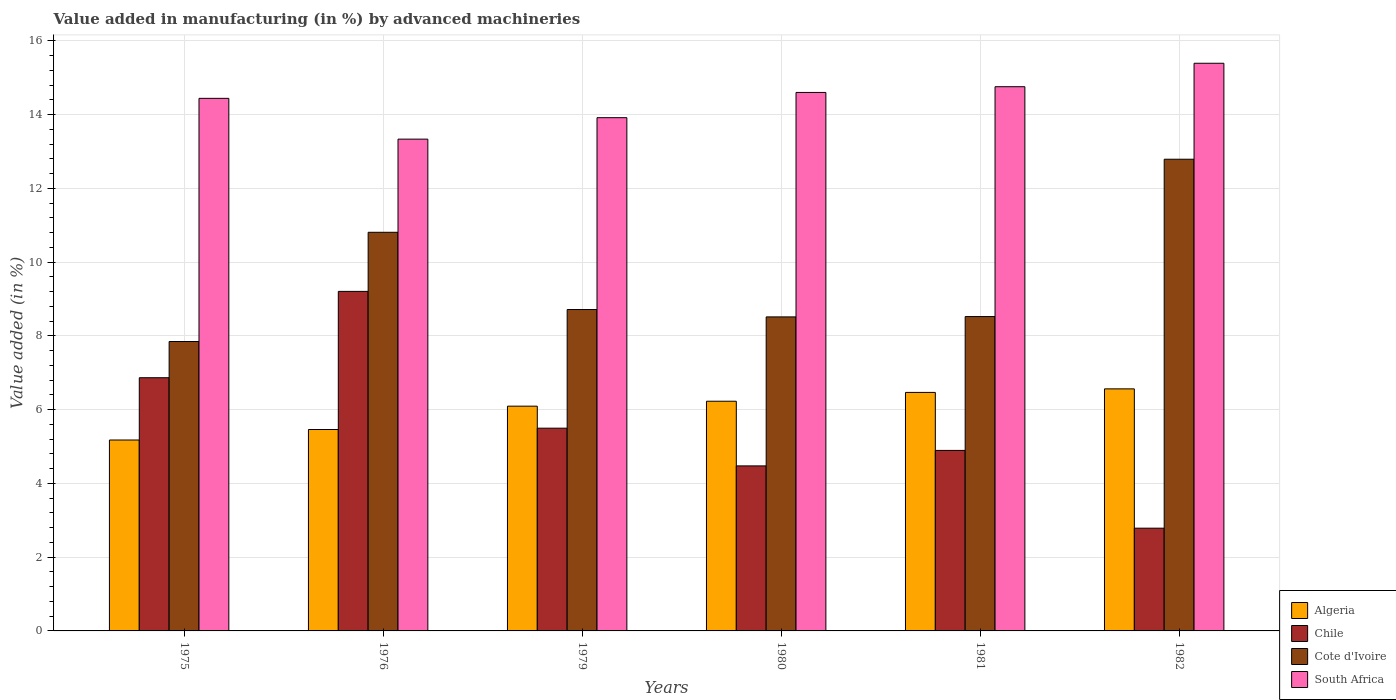How many groups of bars are there?
Make the answer very short. 6. Are the number of bars on each tick of the X-axis equal?
Offer a very short reply. Yes. How many bars are there on the 1st tick from the left?
Offer a terse response. 4. In how many cases, is the number of bars for a given year not equal to the number of legend labels?
Your answer should be compact. 0. What is the percentage of value added in manufacturing by advanced machineries in Chile in 1982?
Provide a short and direct response. 2.79. Across all years, what is the maximum percentage of value added in manufacturing by advanced machineries in Chile?
Your answer should be compact. 9.21. Across all years, what is the minimum percentage of value added in manufacturing by advanced machineries in Algeria?
Offer a terse response. 5.18. In which year was the percentage of value added in manufacturing by advanced machineries in Chile maximum?
Offer a terse response. 1976. In which year was the percentage of value added in manufacturing by advanced machineries in South Africa minimum?
Your response must be concise. 1976. What is the total percentage of value added in manufacturing by advanced machineries in Chile in the graph?
Provide a short and direct response. 33.73. What is the difference between the percentage of value added in manufacturing by advanced machineries in Cote d'Ivoire in 1981 and that in 1982?
Your answer should be very brief. -4.27. What is the difference between the percentage of value added in manufacturing by advanced machineries in Cote d'Ivoire in 1981 and the percentage of value added in manufacturing by advanced machineries in Chile in 1976?
Give a very brief answer. -0.68. What is the average percentage of value added in manufacturing by advanced machineries in Cote d'Ivoire per year?
Ensure brevity in your answer.  9.54. In the year 1981, what is the difference between the percentage of value added in manufacturing by advanced machineries in Algeria and percentage of value added in manufacturing by advanced machineries in Chile?
Offer a very short reply. 1.57. What is the ratio of the percentage of value added in manufacturing by advanced machineries in Cote d'Ivoire in 1975 to that in 1982?
Offer a terse response. 0.61. Is the percentage of value added in manufacturing by advanced machineries in South Africa in 1975 less than that in 1979?
Keep it short and to the point. No. Is the difference between the percentage of value added in manufacturing by advanced machineries in Algeria in 1975 and 1982 greater than the difference between the percentage of value added in manufacturing by advanced machineries in Chile in 1975 and 1982?
Offer a very short reply. No. What is the difference between the highest and the second highest percentage of value added in manufacturing by advanced machineries in Algeria?
Offer a terse response. 0.1. What is the difference between the highest and the lowest percentage of value added in manufacturing by advanced machineries in Chile?
Ensure brevity in your answer.  6.42. In how many years, is the percentage of value added in manufacturing by advanced machineries in Chile greater than the average percentage of value added in manufacturing by advanced machineries in Chile taken over all years?
Your answer should be very brief. 2. Is the sum of the percentage of value added in manufacturing by advanced machineries in South Africa in 1976 and 1981 greater than the maximum percentage of value added in manufacturing by advanced machineries in Cote d'Ivoire across all years?
Make the answer very short. Yes. Is it the case that in every year, the sum of the percentage of value added in manufacturing by advanced machineries in Algeria and percentage of value added in manufacturing by advanced machineries in South Africa is greater than the sum of percentage of value added in manufacturing by advanced machineries in Chile and percentage of value added in manufacturing by advanced machineries in Cote d'Ivoire?
Provide a succinct answer. Yes. What does the 1st bar from the left in 1980 represents?
Provide a succinct answer. Algeria. How many bars are there?
Offer a terse response. 24. Are all the bars in the graph horizontal?
Offer a very short reply. No. What is the difference between two consecutive major ticks on the Y-axis?
Offer a terse response. 2. Does the graph contain any zero values?
Provide a succinct answer. No. Where does the legend appear in the graph?
Give a very brief answer. Bottom right. What is the title of the graph?
Ensure brevity in your answer.  Value added in manufacturing (in %) by advanced machineries. What is the label or title of the X-axis?
Your response must be concise. Years. What is the label or title of the Y-axis?
Ensure brevity in your answer.  Value added (in %). What is the Value added (in %) in Algeria in 1975?
Keep it short and to the point. 5.18. What is the Value added (in %) of Chile in 1975?
Ensure brevity in your answer.  6.87. What is the Value added (in %) of Cote d'Ivoire in 1975?
Make the answer very short. 7.85. What is the Value added (in %) of South Africa in 1975?
Offer a very short reply. 14.44. What is the Value added (in %) of Algeria in 1976?
Offer a very short reply. 5.46. What is the Value added (in %) in Chile in 1976?
Your answer should be compact. 9.21. What is the Value added (in %) of Cote d'Ivoire in 1976?
Give a very brief answer. 10.81. What is the Value added (in %) in South Africa in 1976?
Ensure brevity in your answer.  13.34. What is the Value added (in %) of Algeria in 1979?
Your answer should be very brief. 6.1. What is the Value added (in %) in Chile in 1979?
Ensure brevity in your answer.  5.5. What is the Value added (in %) of Cote d'Ivoire in 1979?
Offer a very short reply. 8.72. What is the Value added (in %) in South Africa in 1979?
Give a very brief answer. 13.92. What is the Value added (in %) of Algeria in 1980?
Your answer should be compact. 6.23. What is the Value added (in %) in Chile in 1980?
Make the answer very short. 4.48. What is the Value added (in %) in Cote d'Ivoire in 1980?
Provide a succinct answer. 8.52. What is the Value added (in %) of South Africa in 1980?
Offer a very short reply. 14.6. What is the Value added (in %) in Algeria in 1981?
Keep it short and to the point. 6.47. What is the Value added (in %) of Chile in 1981?
Give a very brief answer. 4.9. What is the Value added (in %) of Cote d'Ivoire in 1981?
Your answer should be compact. 8.53. What is the Value added (in %) of South Africa in 1981?
Your answer should be very brief. 14.76. What is the Value added (in %) in Algeria in 1982?
Your answer should be very brief. 6.56. What is the Value added (in %) of Chile in 1982?
Give a very brief answer. 2.79. What is the Value added (in %) of Cote d'Ivoire in 1982?
Your answer should be very brief. 12.79. What is the Value added (in %) in South Africa in 1982?
Offer a terse response. 15.4. Across all years, what is the maximum Value added (in %) of Algeria?
Keep it short and to the point. 6.56. Across all years, what is the maximum Value added (in %) of Chile?
Make the answer very short. 9.21. Across all years, what is the maximum Value added (in %) in Cote d'Ivoire?
Provide a succinct answer. 12.79. Across all years, what is the maximum Value added (in %) in South Africa?
Your answer should be very brief. 15.4. Across all years, what is the minimum Value added (in %) in Algeria?
Make the answer very short. 5.18. Across all years, what is the minimum Value added (in %) in Chile?
Your answer should be very brief. 2.79. Across all years, what is the minimum Value added (in %) in Cote d'Ivoire?
Your response must be concise. 7.85. Across all years, what is the minimum Value added (in %) of South Africa?
Make the answer very short. 13.34. What is the total Value added (in %) in Algeria in the graph?
Provide a short and direct response. 36. What is the total Value added (in %) of Chile in the graph?
Give a very brief answer. 33.73. What is the total Value added (in %) of Cote d'Ivoire in the graph?
Ensure brevity in your answer.  57.21. What is the total Value added (in %) in South Africa in the graph?
Your response must be concise. 86.46. What is the difference between the Value added (in %) in Algeria in 1975 and that in 1976?
Your answer should be very brief. -0.28. What is the difference between the Value added (in %) in Chile in 1975 and that in 1976?
Offer a terse response. -2.34. What is the difference between the Value added (in %) of Cote d'Ivoire in 1975 and that in 1976?
Your answer should be compact. -2.96. What is the difference between the Value added (in %) of South Africa in 1975 and that in 1976?
Your answer should be very brief. 1.11. What is the difference between the Value added (in %) of Algeria in 1975 and that in 1979?
Your answer should be compact. -0.92. What is the difference between the Value added (in %) of Chile in 1975 and that in 1979?
Provide a short and direct response. 1.37. What is the difference between the Value added (in %) of Cote d'Ivoire in 1975 and that in 1979?
Provide a short and direct response. -0.87. What is the difference between the Value added (in %) of South Africa in 1975 and that in 1979?
Ensure brevity in your answer.  0.52. What is the difference between the Value added (in %) of Algeria in 1975 and that in 1980?
Your answer should be very brief. -1.05. What is the difference between the Value added (in %) in Chile in 1975 and that in 1980?
Give a very brief answer. 2.39. What is the difference between the Value added (in %) in Cote d'Ivoire in 1975 and that in 1980?
Your answer should be compact. -0.67. What is the difference between the Value added (in %) in South Africa in 1975 and that in 1980?
Give a very brief answer. -0.16. What is the difference between the Value added (in %) in Algeria in 1975 and that in 1981?
Provide a succinct answer. -1.29. What is the difference between the Value added (in %) in Chile in 1975 and that in 1981?
Your response must be concise. 1.97. What is the difference between the Value added (in %) of Cote d'Ivoire in 1975 and that in 1981?
Offer a very short reply. -0.68. What is the difference between the Value added (in %) of South Africa in 1975 and that in 1981?
Ensure brevity in your answer.  -0.32. What is the difference between the Value added (in %) of Algeria in 1975 and that in 1982?
Your answer should be very brief. -1.39. What is the difference between the Value added (in %) in Chile in 1975 and that in 1982?
Provide a succinct answer. 4.08. What is the difference between the Value added (in %) in Cote d'Ivoire in 1975 and that in 1982?
Provide a short and direct response. -4.94. What is the difference between the Value added (in %) in South Africa in 1975 and that in 1982?
Your answer should be compact. -0.95. What is the difference between the Value added (in %) of Algeria in 1976 and that in 1979?
Provide a short and direct response. -0.63. What is the difference between the Value added (in %) in Chile in 1976 and that in 1979?
Provide a short and direct response. 3.71. What is the difference between the Value added (in %) of Cote d'Ivoire in 1976 and that in 1979?
Provide a short and direct response. 2.09. What is the difference between the Value added (in %) of South Africa in 1976 and that in 1979?
Make the answer very short. -0.58. What is the difference between the Value added (in %) in Algeria in 1976 and that in 1980?
Make the answer very short. -0.77. What is the difference between the Value added (in %) in Chile in 1976 and that in 1980?
Make the answer very short. 4.73. What is the difference between the Value added (in %) of Cote d'Ivoire in 1976 and that in 1980?
Your answer should be very brief. 2.29. What is the difference between the Value added (in %) in South Africa in 1976 and that in 1980?
Ensure brevity in your answer.  -1.27. What is the difference between the Value added (in %) in Algeria in 1976 and that in 1981?
Your answer should be compact. -1.01. What is the difference between the Value added (in %) of Chile in 1976 and that in 1981?
Offer a terse response. 4.31. What is the difference between the Value added (in %) in Cote d'Ivoire in 1976 and that in 1981?
Offer a very short reply. 2.29. What is the difference between the Value added (in %) in South Africa in 1976 and that in 1981?
Provide a short and direct response. -1.42. What is the difference between the Value added (in %) of Algeria in 1976 and that in 1982?
Your response must be concise. -1.1. What is the difference between the Value added (in %) in Chile in 1976 and that in 1982?
Your response must be concise. 6.42. What is the difference between the Value added (in %) of Cote d'Ivoire in 1976 and that in 1982?
Keep it short and to the point. -1.98. What is the difference between the Value added (in %) of South Africa in 1976 and that in 1982?
Provide a short and direct response. -2.06. What is the difference between the Value added (in %) of Algeria in 1979 and that in 1980?
Offer a very short reply. -0.13. What is the difference between the Value added (in %) of Chile in 1979 and that in 1980?
Make the answer very short. 1.02. What is the difference between the Value added (in %) in Cote d'Ivoire in 1979 and that in 1980?
Your response must be concise. 0.2. What is the difference between the Value added (in %) in South Africa in 1979 and that in 1980?
Your answer should be compact. -0.68. What is the difference between the Value added (in %) of Algeria in 1979 and that in 1981?
Offer a terse response. -0.37. What is the difference between the Value added (in %) in Chile in 1979 and that in 1981?
Give a very brief answer. 0.6. What is the difference between the Value added (in %) of Cote d'Ivoire in 1979 and that in 1981?
Provide a succinct answer. 0.19. What is the difference between the Value added (in %) in South Africa in 1979 and that in 1981?
Ensure brevity in your answer.  -0.84. What is the difference between the Value added (in %) in Algeria in 1979 and that in 1982?
Offer a terse response. -0.47. What is the difference between the Value added (in %) of Chile in 1979 and that in 1982?
Keep it short and to the point. 2.71. What is the difference between the Value added (in %) in Cote d'Ivoire in 1979 and that in 1982?
Give a very brief answer. -4.08. What is the difference between the Value added (in %) of South Africa in 1979 and that in 1982?
Make the answer very short. -1.48. What is the difference between the Value added (in %) of Algeria in 1980 and that in 1981?
Give a very brief answer. -0.24. What is the difference between the Value added (in %) in Chile in 1980 and that in 1981?
Your answer should be compact. -0.42. What is the difference between the Value added (in %) of Cote d'Ivoire in 1980 and that in 1981?
Your answer should be very brief. -0.01. What is the difference between the Value added (in %) in South Africa in 1980 and that in 1981?
Provide a succinct answer. -0.16. What is the difference between the Value added (in %) in Algeria in 1980 and that in 1982?
Offer a very short reply. -0.34. What is the difference between the Value added (in %) in Chile in 1980 and that in 1982?
Offer a terse response. 1.69. What is the difference between the Value added (in %) in Cote d'Ivoire in 1980 and that in 1982?
Your response must be concise. -4.28. What is the difference between the Value added (in %) in South Africa in 1980 and that in 1982?
Offer a very short reply. -0.79. What is the difference between the Value added (in %) of Algeria in 1981 and that in 1982?
Make the answer very short. -0.1. What is the difference between the Value added (in %) of Chile in 1981 and that in 1982?
Ensure brevity in your answer.  2.11. What is the difference between the Value added (in %) of Cote d'Ivoire in 1981 and that in 1982?
Make the answer very short. -4.27. What is the difference between the Value added (in %) of South Africa in 1981 and that in 1982?
Give a very brief answer. -0.64. What is the difference between the Value added (in %) of Algeria in 1975 and the Value added (in %) of Chile in 1976?
Give a very brief answer. -4.03. What is the difference between the Value added (in %) of Algeria in 1975 and the Value added (in %) of Cote d'Ivoire in 1976?
Provide a short and direct response. -5.63. What is the difference between the Value added (in %) in Algeria in 1975 and the Value added (in %) in South Africa in 1976?
Keep it short and to the point. -8.16. What is the difference between the Value added (in %) in Chile in 1975 and the Value added (in %) in Cote d'Ivoire in 1976?
Ensure brevity in your answer.  -3.94. What is the difference between the Value added (in %) of Chile in 1975 and the Value added (in %) of South Africa in 1976?
Ensure brevity in your answer.  -6.47. What is the difference between the Value added (in %) in Cote d'Ivoire in 1975 and the Value added (in %) in South Africa in 1976?
Offer a terse response. -5.49. What is the difference between the Value added (in %) of Algeria in 1975 and the Value added (in %) of Chile in 1979?
Give a very brief answer. -0.32. What is the difference between the Value added (in %) of Algeria in 1975 and the Value added (in %) of Cote d'Ivoire in 1979?
Provide a succinct answer. -3.54. What is the difference between the Value added (in %) in Algeria in 1975 and the Value added (in %) in South Africa in 1979?
Offer a very short reply. -8.74. What is the difference between the Value added (in %) in Chile in 1975 and the Value added (in %) in Cote d'Ivoire in 1979?
Provide a short and direct response. -1.85. What is the difference between the Value added (in %) in Chile in 1975 and the Value added (in %) in South Africa in 1979?
Offer a very short reply. -7.05. What is the difference between the Value added (in %) of Cote d'Ivoire in 1975 and the Value added (in %) of South Africa in 1979?
Offer a terse response. -6.07. What is the difference between the Value added (in %) in Algeria in 1975 and the Value added (in %) in Chile in 1980?
Give a very brief answer. 0.7. What is the difference between the Value added (in %) of Algeria in 1975 and the Value added (in %) of Cote d'Ivoire in 1980?
Offer a very short reply. -3.34. What is the difference between the Value added (in %) in Algeria in 1975 and the Value added (in %) in South Africa in 1980?
Ensure brevity in your answer.  -9.43. What is the difference between the Value added (in %) of Chile in 1975 and the Value added (in %) of Cote d'Ivoire in 1980?
Your answer should be very brief. -1.65. What is the difference between the Value added (in %) in Chile in 1975 and the Value added (in %) in South Africa in 1980?
Provide a succinct answer. -7.74. What is the difference between the Value added (in %) in Cote d'Ivoire in 1975 and the Value added (in %) in South Africa in 1980?
Offer a terse response. -6.75. What is the difference between the Value added (in %) in Algeria in 1975 and the Value added (in %) in Chile in 1981?
Offer a terse response. 0.28. What is the difference between the Value added (in %) in Algeria in 1975 and the Value added (in %) in Cote d'Ivoire in 1981?
Your response must be concise. -3.35. What is the difference between the Value added (in %) of Algeria in 1975 and the Value added (in %) of South Africa in 1981?
Your answer should be compact. -9.58. What is the difference between the Value added (in %) of Chile in 1975 and the Value added (in %) of Cote d'Ivoire in 1981?
Make the answer very short. -1.66. What is the difference between the Value added (in %) of Chile in 1975 and the Value added (in %) of South Africa in 1981?
Ensure brevity in your answer.  -7.89. What is the difference between the Value added (in %) of Cote d'Ivoire in 1975 and the Value added (in %) of South Africa in 1981?
Keep it short and to the point. -6.91. What is the difference between the Value added (in %) of Algeria in 1975 and the Value added (in %) of Chile in 1982?
Your response must be concise. 2.39. What is the difference between the Value added (in %) of Algeria in 1975 and the Value added (in %) of Cote d'Ivoire in 1982?
Your response must be concise. -7.62. What is the difference between the Value added (in %) in Algeria in 1975 and the Value added (in %) in South Africa in 1982?
Make the answer very short. -10.22. What is the difference between the Value added (in %) in Chile in 1975 and the Value added (in %) in Cote d'Ivoire in 1982?
Your response must be concise. -5.93. What is the difference between the Value added (in %) in Chile in 1975 and the Value added (in %) in South Africa in 1982?
Offer a terse response. -8.53. What is the difference between the Value added (in %) of Cote d'Ivoire in 1975 and the Value added (in %) of South Africa in 1982?
Your response must be concise. -7.55. What is the difference between the Value added (in %) of Algeria in 1976 and the Value added (in %) of Chile in 1979?
Your response must be concise. -0.04. What is the difference between the Value added (in %) of Algeria in 1976 and the Value added (in %) of Cote d'Ivoire in 1979?
Ensure brevity in your answer.  -3.25. What is the difference between the Value added (in %) in Algeria in 1976 and the Value added (in %) in South Africa in 1979?
Offer a very short reply. -8.46. What is the difference between the Value added (in %) in Chile in 1976 and the Value added (in %) in Cote d'Ivoire in 1979?
Offer a terse response. 0.49. What is the difference between the Value added (in %) in Chile in 1976 and the Value added (in %) in South Africa in 1979?
Make the answer very short. -4.71. What is the difference between the Value added (in %) in Cote d'Ivoire in 1976 and the Value added (in %) in South Africa in 1979?
Keep it short and to the point. -3.11. What is the difference between the Value added (in %) of Algeria in 1976 and the Value added (in %) of Chile in 1980?
Ensure brevity in your answer.  0.99. What is the difference between the Value added (in %) of Algeria in 1976 and the Value added (in %) of Cote d'Ivoire in 1980?
Make the answer very short. -3.05. What is the difference between the Value added (in %) of Algeria in 1976 and the Value added (in %) of South Africa in 1980?
Your response must be concise. -9.14. What is the difference between the Value added (in %) of Chile in 1976 and the Value added (in %) of Cote d'Ivoire in 1980?
Provide a succinct answer. 0.69. What is the difference between the Value added (in %) in Chile in 1976 and the Value added (in %) in South Africa in 1980?
Make the answer very short. -5.4. What is the difference between the Value added (in %) of Cote d'Ivoire in 1976 and the Value added (in %) of South Africa in 1980?
Provide a short and direct response. -3.79. What is the difference between the Value added (in %) of Algeria in 1976 and the Value added (in %) of Chile in 1981?
Give a very brief answer. 0.57. What is the difference between the Value added (in %) in Algeria in 1976 and the Value added (in %) in Cote d'Ivoire in 1981?
Provide a short and direct response. -3.06. What is the difference between the Value added (in %) in Algeria in 1976 and the Value added (in %) in South Africa in 1981?
Your answer should be compact. -9.3. What is the difference between the Value added (in %) of Chile in 1976 and the Value added (in %) of Cote d'Ivoire in 1981?
Provide a succinct answer. 0.68. What is the difference between the Value added (in %) of Chile in 1976 and the Value added (in %) of South Africa in 1981?
Keep it short and to the point. -5.55. What is the difference between the Value added (in %) in Cote d'Ivoire in 1976 and the Value added (in %) in South Africa in 1981?
Ensure brevity in your answer.  -3.95. What is the difference between the Value added (in %) of Algeria in 1976 and the Value added (in %) of Chile in 1982?
Give a very brief answer. 2.68. What is the difference between the Value added (in %) in Algeria in 1976 and the Value added (in %) in Cote d'Ivoire in 1982?
Provide a succinct answer. -7.33. What is the difference between the Value added (in %) of Algeria in 1976 and the Value added (in %) of South Africa in 1982?
Ensure brevity in your answer.  -9.93. What is the difference between the Value added (in %) of Chile in 1976 and the Value added (in %) of Cote d'Ivoire in 1982?
Your response must be concise. -3.58. What is the difference between the Value added (in %) of Chile in 1976 and the Value added (in %) of South Africa in 1982?
Give a very brief answer. -6.19. What is the difference between the Value added (in %) of Cote d'Ivoire in 1976 and the Value added (in %) of South Africa in 1982?
Give a very brief answer. -4.58. What is the difference between the Value added (in %) of Algeria in 1979 and the Value added (in %) of Chile in 1980?
Give a very brief answer. 1.62. What is the difference between the Value added (in %) in Algeria in 1979 and the Value added (in %) in Cote d'Ivoire in 1980?
Your answer should be very brief. -2.42. What is the difference between the Value added (in %) in Algeria in 1979 and the Value added (in %) in South Africa in 1980?
Provide a short and direct response. -8.51. What is the difference between the Value added (in %) in Chile in 1979 and the Value added (in %) in Cote d'Ivoire in 1980?
Your answer should be compact. -3.02. What is the difference between the Value added (in %) of Chile in 1979 and the Value added (in %) of South Africa in 1980?
Ensure brevity in your answer.  -9.11. What is the difference between the Value added (in %) in Cote d'Ivoire in 1979 and the Value added (in %) in South Africa in 1980?
Your response must be concise. -5.89. What is the difference between the Value added (in %) of Algeria in 1979 and the Value added (in %) of Cote d'Ivoire in 1981?
Offer a terse response. -2.43. What is the difference between the Value added (in %) in Algeria in 1979 and the Value added (in %) in South Africa in 1981?
Provide a short and direct response. -8.66. What is the difference between the Value added (in %) in Chile in 1979 and the Value added (in %) in Cote d'Ivoire in 1981?
Provide a short and direct response. -3.03. What is the difference between the Value added (in %) in Chile in 1979 and the Value added (in %) in South Africa in 1981?
Offer a terse response. -9.26. What is the difference between the Value added (in %) of Cote d'Ivoire in 1979 and the Value added (in %) of South Africa in 1981?
Your answer should be compact. -6.04. What is the difference between the Value added (in %) of Algeria in 1979 and the Value added (in %) of Chile in 1982?
Make the answer very short. 3.31. What is the difference between the Value added (in %) of Algeria in 1979 and the Value added (in %) of Cote d'Ivoire in 1982?
Your response must be concise. -6.7. What is the difference between the Value added (in %) of Algeria in 1979 and the Value added (in %) of South Africa in 1982?
Keep it short and to the point. -9.3. What is the difference between the Value added (in %) of Chile in 1979 and the Value added (in %) of Cote d'Ivoire in 1982?
Offer a very short reply. -7.29. What is the difference between the Value added (in %) in Chile in 1979 and the Value added (in %) in South Africa in 1982?
Make the answer very short. -9.9. What is the difference between the Value added (in %) of Cote d'Ivoire in 1979 and the Value added (in %) of South Africa in 1982?
Keep it short and to the point. -6.68. What is the difference between the Value added (in %) in Algeria in 1980 and the Value added (in %) in Chile in 1981?
Give a very brief answer. 1.33. What is the difference between the Value added (in %) of Algeria in 1980 and the Value added (in %) of Cote d'Ivoire in 1981?
Your answer should be very brief. -2.3. What is the difference between the Value added (in %) of Algeria in 1980 and the Value added (in %) of South Africa in 1981?
Ensure brevity in your answer.  -8.53. What is the difference between the Value added (in %) of Chile in 1980 and the Value added (in %) of Cote d'Ivoire in 1981?
Give a very brief answer. -4.05. What is the difference between the Value added (in %) in Chile in 1980 and the Value added (in %) in South Africa in 1981?
Make the answer very short. -10.28. What is the difference between the Value added (in %) of Cote d'Ivoire in 1980 and the Value added (in %) of South Africa in 1981?
Provide a short and direct response. -6.24. What is the difference between the Value added (in %) of Algeria in 1980 and the Value added (in %) of Chile in 1982?
Offer a terse response. 3.44. What is the difference between the Value added (in %) of Algeria in 1980 and the Value added (in %) of Cote d'Ivoire in 1982?
Offer a terse response. -6.56. What is the difference between the Value added (in %) of Algeria in 1980 and the Value added (in %) of South Africa in 1982?
Provide a succinct answer. -9.17. What is the difference between the Value added (in %) of Chile in 1980 and the Value added (in %) of Cote d'Ivoire in 1982?
Offer a terse response. -8.32. What is the difference between the Value added (in %) of Chile in 1980 and the Value added (in %) of South Africa in 1982?
Keep it short and to the point. -10.92. What is the difference between the Value added (in %) in Cote d'Ivoire in 1980 and the Value added (in %) in South Africa in 1982?
Provide a succinct answer. -6.88. What is the difference between the Value added (in %) in Algeria in 1981 and the Value added (in %) in Chile in 1982?
Your response must be concise. 3.68. What is the difference between the Value added (in %) in Algeria in 1981 and the Value added (in %) in Cote d'Ivoire in 1982?
Offer a terse response. -6.32. What is the difference between the Value added (in %) of Algeria in 1981 and the Value added (in %) of South Africa in 1982?
Your answer should be compact. -8.93. What is the difference between the Value added (in %) in Chile in 1981 and the Value added (in %) in Cote d'Ivoire in 1982?
Your answer should be very brief. -7.9. What is the difference between the Value added (in %) in Chile in 1981 and the Value added (in %) in South Africa in 1982?
Keep it short and to the point. -10.5. What is the difference between the Value added (in %) of Cote d'Ivoire in 1981 and the Value added (in %) of South Africa in 1982?
Make the answer very short. -6.87. What is the average Value added (in %) of Algeria per year?
Provide a short and direct response. 6. What is the average Value added (in %) of Chile per year?
Offer a very short reply. 5.62. What is the average Value added (in %) in Cote d'Ivoire per year?
Give a very brief answer. 9.54. What is the average Value added (in %) in South Africa per year?
Provide a short and direct response. 14.41. In the year 1975, what is the difference between the Value added (in %) of Algeria and Value added (in %) of Chile?
Offer a very short reply. -1.69. In the year 1975, what is the difference between the Value added (in %) of Algeria and Value added (in %) of Cote d'Ivoire?
Ensure brevity in your answer.  -2.67. In the year 1975, what is the difference between the Value added (in %) of Algeria and Value added (in %) of South Africa?
Your answer should be compact. -9.27. In the year 1975, what is the difference between the Value added (in %) of Chile and Value added (in %) of Cote d'Ivoire?
Keep it short and to the point. -0.98. In the year 1975, what is the difference between the Value added (in %) in Chile and Value added (in %) in South Africa?
Provide a short and direct response. -7.58. In the year 1975, what is the difference between the Value added (in %) in Cote d'Ivoire and Value added (in %) in South Africa?
Keep it short and to the point. -6.59. In the year 1976, what is the difference between the Value added (in %) in Algeria and Value added (in %) in Chile?
Provide a short and direct response. -3.75. In the year 1976, what is the difference between the Value added (in %) of Algeria and Value added (in %) of Cote d'Ivoire?
Provide a succinct answer. -5.35. In the year 1976, what is the difference between the Value added (in %) of Algeria and Value added (in %) of South Africa?
Ensure brevity in your answer.  -7.88. In the year 1976, what is the difference between the Value added (in %) in Chile and Value added (in %) in Cote d'Ivoire?
Your answer should be very brief. -1.6. In the year 1976, what is the difference between the Value added (in %) of Chile and Value added (in %) of South Africa?
Provide a short and direct response. -4.13. In the year 1976, what is the difference between the Value added (in %) in Cote d'Ivoire and Value added (in %) in South Africa?
Offer a terse response. -2.53. In the year 1979, what is the difference between the Value added (in %) in Algeria and Value added (in %) in Chile?
Ensure brevity in your answer.  0.6. In the year 1979, what is the difference between the Value added (in %) in Algeria and Value added (in %) in Cote d'Ivoire?
Keep it short and to the point. -2.62. In the year 1979, what is the difference between the Value added (in %) in Algeria and Value added (in %) in South Africa?
Your answer should be very brief. -7.82. In the year 1979, what is the difference between the Value added (in %) in Chile and Value added (in %) in Cote d'Ivoire?
Offer a very short reply. -3.22. In the year 1979, what is the difference between the Value added (in %) in Chile and Value added (in %) in South Africa?
Keep it short and to the point. -8.42. In the year 1979, what is the difference between the Value added (in %) in Cote d'Ivoire and Value added (in %) in South Africa?
Keep it short and to the point. -5.2. In the year 1980, what is the difference between the Value added (in %) in Algeria and Value added (in %) in Chile?
Make the answer very short. 1.75. In the year 1980, what is the difference between the Value added (in %) of Algeria and Value added (in %) of Cote d'Ivoire?
Keep it short and to the point. -2.29. In the year 1980, what is the difference between the Value added (in %) in Algeria and Value added (in %) in South Africa?
Ensure brevity in your answer.  -8.37. In the year 1980, what is the difference between the Value added (in %) of Chile and Value added (in %) of Cote d'Ivoire?
Offer a terse response. -4.04. In the year 1980, what is the difference between the Value added (in %) in Chile and Value added (in %) in South Africa?
Offer a very short reply. -10.13. In the year 1980, what is the difference between the Value added (in %) in Cote d'Ivoire and Value added (in %) in South Africa?
Make the answer very short. -6.09. In the year 1981, what is the difference between the Value added (in %) in Algeria and Value added (in %) in Chile?
Provide a succinct answer. 1.57. In the year 1981, what is the difference between the Value added (in %) in Algeria and Value added (in %) in Cote d'Ivoire?
Your response must be concise. -2.06. In the year 1981, what is the difference between the Value added (in %) in Algeria and Value added (in %) in South Africa?
Ensure brevity in your answer.  -8.29. In the year 1981, what is the difference between the Value added (in %) in Chile and Value added (in %) in Cote d'Ivoire?
Your answer should be very brief. -3.63. In the year 1981, what is the difference between the Value added (in %) of Chile and Value added (in %) of South Africa?
Your answer should be compact. -9.86. In the year 1981, what is the difference between the Value added (in %) of Cote d'Ivoire and Value added (in %) of South Africa?
Your response must be concise. -6.23. In the year 1982, what is the difference between the Value added (in %) in Algeria and Value added (in %) in Chile?
Provide a short and direct response. 3.78. In the year 1982, what is the difference between the Value added (in %) of Algeria and Value added (in %) of Cote d'Ivoire?
Ensure brevity in your answer.  -6.23. In the year 1982, what is the difference between the Value added (in %) in Algeria and Value added (in %) in South Africa?
Keep it short and to the point. -8.83. In the year 1982, what is the difference between the Value added (in %) in Chile and Value added (in %) in Cote d'Ivoire?
Offer a terse response. -10.01. In the year 1982, what is the difference between the Value added (in %) in Chile and Value added (in %) in South Africa?
Provide a short and direct response. -12.61. In the year 1982, what is the difference between the Value added (in %) in Cote d'Ivoire and Value added (in %) in South Africa?
Your answer should be compact. -2.6. What is the ratio of the Value added (in %) in Algeria in 1975 to that in 1976?
Your answer should be compact. 0.95. What is the ratio of the Value added (in %) of Chile in 1975 to that in 1976?
Offer a very short reply. 0.75. What is the ratio of the Value added (in %) in Cote d'Ivoire in 1975 to that in 1976?
Offer a terse response. 0.73. What is the ratio of the Value added (in %) in South Africa in 1975 to that in 1976?
Your answer should be compact. 1.08. What is the ratio of the Value added (in %) in Algeria in 1975 to that in 1979?
Provide a short and direct response. 0.85. What is the ratio of the Value added (in %) of Chile in 1975 to that in 1979?
Give a very brief answer. 1.25. What is the ratio of the Value added (in %) of Cote d'Ivoire in 1975 to that in 1979?
Your answer should be compact. 0.9. What is the ratio of the Value added (in %) in South Africa in 1975 to that in 1979?
Offer a very short reply. 1.04. What is the ratio of the Value added (in %) in Algeria in 1975 to that in 1980?
Offer a terse response. 0.83. What is the ratio of the Value added (in %) of Chile in 1975 to that in 1980?
Your response must be concise. 1.53. What is the ratio of the Value added (in %) of Cote d'Ivoire in 1975 to that in 1980?
Make the answer very short. 0.92. What is the ratio of the Value added (in %) of Algeria in 1975 to that in 1981?
Offer a very short reply. 0.8. What is the ratio of the Value added (in %) of Chile in 1975 to that in 1981?
Offer a very short reply. 1.4. What is the ratio of the Value added (in %) of Cote d'Ivoire in 1975 to that in 1981?
Give a very brief answer. 0.92. What is the ratio of the Value added (in %) of South Africa in 1975 to that in 1981?
Make the answer very short. 0.98. What is the ratio of the Value added (in %) in Algeria in 1975 to that in 1982?
Offer a very short reply. 0.79. What is the ratio of the Value added (in %) in Chile in 1975 to that in 1982?
Your answer should be compact. 2.46. What is the ratio of the Value added (in %) in Cote d'Ivoire in 1975 to that in 1982?
Offer a terse response. 0.61. What is the ratio of the Value added (in %) in South Africa in 1975 to that in 1982?
Provide a short and direct response. 0.94. What is the ratio of the Value added (in %) of Algeria in 1976 to that in 1979?
Your answer should be very brief. 0.9. What is the ratio of the Value added (in %) in Chile in 1976 to that in 1979?
Provide a succinct answer. 1.67. What is the ratio of the Value added (in %) in Cote d'Ivoire in 1976 to that in 1979?
Your answer should be very brief. 1.24. What is the ratio of the Value added (in %) in South Africa in 1976 to that in 1979?
Your answer should be compact. 0.96. What is the ratio of the Value added (in %) of Algeria in 1976 to that in 1980?
Ensure brevity in your answer.  0.88. What is the ratio of the Value added (in %) in Chile in 1976 to that in 1980?
Your response must be concise. 2.06. What is the ratio of the Value added (in %) in Cote d'Ivoire in 1976 to that in 1980?
Keep it short and to the point. 1.27. What is the ratio of the Value added (in %) in South Africa in 1976 to that in 1980?
Your answer should be very brief. 0.91. What is the ratio of the Value added (in %) of Algeria in 1976 to that in 1981?
Offer a very short reply. 0.84. What is the ratio of the Value added (in %) of Chile in 1976 to that in 1981?
Your answer should be compact. 1.88. What is the ratio of the Value added (in %) in Cote d'Ivoire in 1976 to that in 1981?
Keep it short and to the point. 1.27. What is the ratio of the Value added (in %) of South Africa in 1976 to that in 1981?
Offer a very short reply. 0.9. What is the ratio of the Value added (in %) in Algeria in 1976 to that in 1982?
Provide a short and direct response. 0.83. What is the ratio of the Value added (in %) in Chile in 1976 to that in 1982?
Provide a succinct answer. 3.3. What is the ratio of the Value added (in %) in Cote d'Ivoire in 1976 to that in 1982?
Keep it short and to the point. 0.85. What is the ratio of the Value added (in %) in South Africa in 1976 to that in 1982?
Ensure brevity in your answer.  0.87. What is the ratio of the Value added (in %) in Algeria in 1979 to that in 1980?
Ensure brevity in your answer.  0.98. What is the ratio of the Value added (in %) in Chile in 1979 to that in 1980?
Ensure brevity in your answer.  1.23. What is the ratio of the Value added (in %) in Cote d'Ivoire in 1979 to that in 1980?
Your response must be concise. 1.02. What is the ratio of the Value added (in %) of South Africa in 1979 to that in 1980?
Provide a succinct answer. 0.95. What is the ratio of the Value added (in %) of Algeria in 1979 to that in 1981?
Your answer should be very brief. 0.94. What is the ratio of the Value added (in %) of Chile in 1979 to that in 1981?
Offer a terse response. 1.12. What is the ratio of the Value added (in %) in Cote d'Ivoire in 1979 to that in 1981?
Offer a very short reply. 1.02. What is the ratio of the Value added (in %) in South Africa in 1979 to that in 1981?
Offer a very short reply. 0.94. What is the ratio of the Value added (in %) of Algeria in 1979 to that in 1982?
Give a very brief answer. 0.93. What is the ratio of the Value added (in %) in Chile in 1979 to that in 1982?
Provide a short and direct response. 1.97. What is the ratio of the Value added (in %) in Cote d'Ivoire in 1979 to that in 1982?
Provide a short and direct response. 0.68. What is the ratio of the Value added (in %) in South Africa in 1979 to that in 1982?
Your answer should be compact. 0.9. What is the ratio of the Value added (in %) in Algeria in 1980 to that in 1981?
Your answer should be very brief. 0.96. What is the ratio of the Value added (in %) of Chile in 1980 to that in 1981?
Offer a very short reply. 0.91. What is the ratio of the Value added (in %) of Cote d'Ivoire in 1980 to that in 1981?
Your answer should be compact. 1. What is the ratio of the Value added (in %) in South Africa in 1980 to that in 1981?
Your answer should be very brief. 0.99. What is the ratio of the Value added (in %) in Algeria in 1980 to that in 1982?
Make the answer very short. 0.95. What is the ratio of the Value added (in %) of Chile in 1980 to that in 1982?
Ensure brevity in your answer.  1.61. What is the ratio of the Value added (in %) in Cote d'Ivoire in 1980 to that in 1982?
Your response must be concise. 0.67. What is the ratio of the Value added (in %) of South Africa in 1980 to that in 1982?
Provide a short and direct response. 0.95. What is the ratio of the Value added (in %) of Algeria in 1981 to that in 1982?
Provide a short and direct response. 0.99. What is the ratio of the Value added (in %) of Chile in 1981 to that in 1982?
Give a very brief answer. 1.76. What is the ratio of the Value added (in %) of Cote d'Ivoire in 1981 to that in 1982?
Your answer should be very brief. 0.67. What is the ratio of the Value added (in %) in South Africa in 1981 to that in 1982?
Offer a terse response. 0.96. What is the difference between the highest and the second highest Value added (in %) in Algeria?
Offer a very short reply. 0.1. What is the difference between the highest and the second highest Value added (in %) of Chile?
Offer a very short reply. 2.34. What is the difference between the highest and the second highest Value added (in %) in Cote d'Ivoire?
Offer a terse response. 1.98. What is the difference between the highest and the second highest Value added (in %) in South Africa?
Your answer should be compact. 0.64. What is the difference between the highest and the lowest Value added (in %) of Algeria?
Give a very brief answer. 1.39. What is the difference between the highest and the lowest Value added (in %) in Chile?
Give a very brief answer. 6.42. What is the difference between the highest and the lowest Value added (in %) of Cote d'Ivoire?
Your answer should be compact. 4.94. What is the difference between the highest and the lowest Value added (in %) of South Africa?
Offer a very short reply. 2.06. 